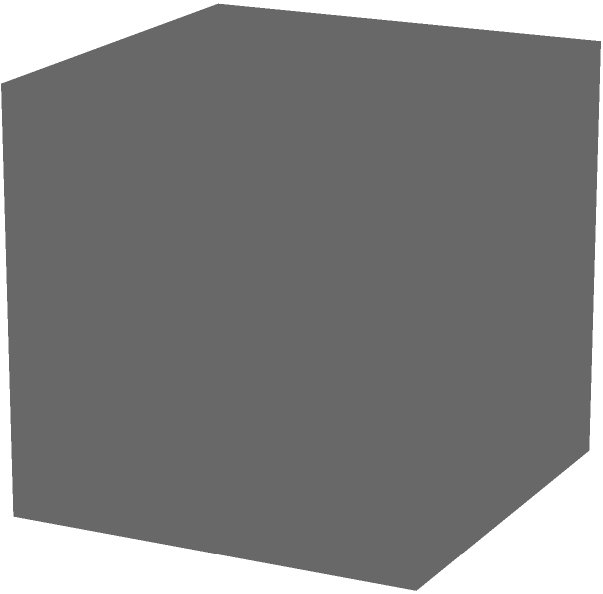In a unit cube, two planes $P_1$ and $P_2$ intersect the cube as shown in the figure. Plane $P_1$ passes through the points (1,1,1), (0,1,0), and (1,0,0), while plane $P_2$ passes through (1,0,0), (1,1,0), and (0,0,1). What is the angle between these two planes? To find the angle between two planes, we need to follow these steps:

1) First, we need to find the normal vectors of both planes.

2) For plane $P_1$:
   - Two vectors on the plane: $\vec{v_1} = (1,1,1) - (0,1,0) = (1,0,1)$ and $\vec{v_2} = (1,1,1) - (1,0,0) = (0,1,1)$
   - Normal vector $\vec{n_1} = \vec{v_1} \times \vec{v_2} = (1,-1,1)$

3) For plane $P_2$:
   - Two vectors on the plane: $\vec{u_1} = (1,0,0) - (1,1,0) = (0,-1,0)$ and $\vec{u_2} = (1,0,0) - (0,0,1) = (1,0,-1)$
   - Normal vector $\vec{n_2} = \vec{u_1} \times \vec{u_2} = (1,1,1)$

4) The angle $\theta$ between the planes is the complement of the angle between their normal vectors:

   $$\cos \theta = |\frac{\vec{n_1} \cdot \vec{n_2}}{|\vec{n_1}||\vec{n_2}|}|$$

5) Calculating:
   $$\cos \theta = |\frac{(1,-1,1) \cdot (1,1,1)}{\sqrt{1^2+(-1)^2+1^2}\sqrt{1^2+1^2+1^2}}| = |\frac{1}{\sqrt{3}\sqrt{3}}| = \frac{1}{3}$$

6) Therefore, $\theta = \arccos(\frac{1}{3})$
Answer: $\arccos(\frac{1}{3})$ radians or approximately 70.53° 